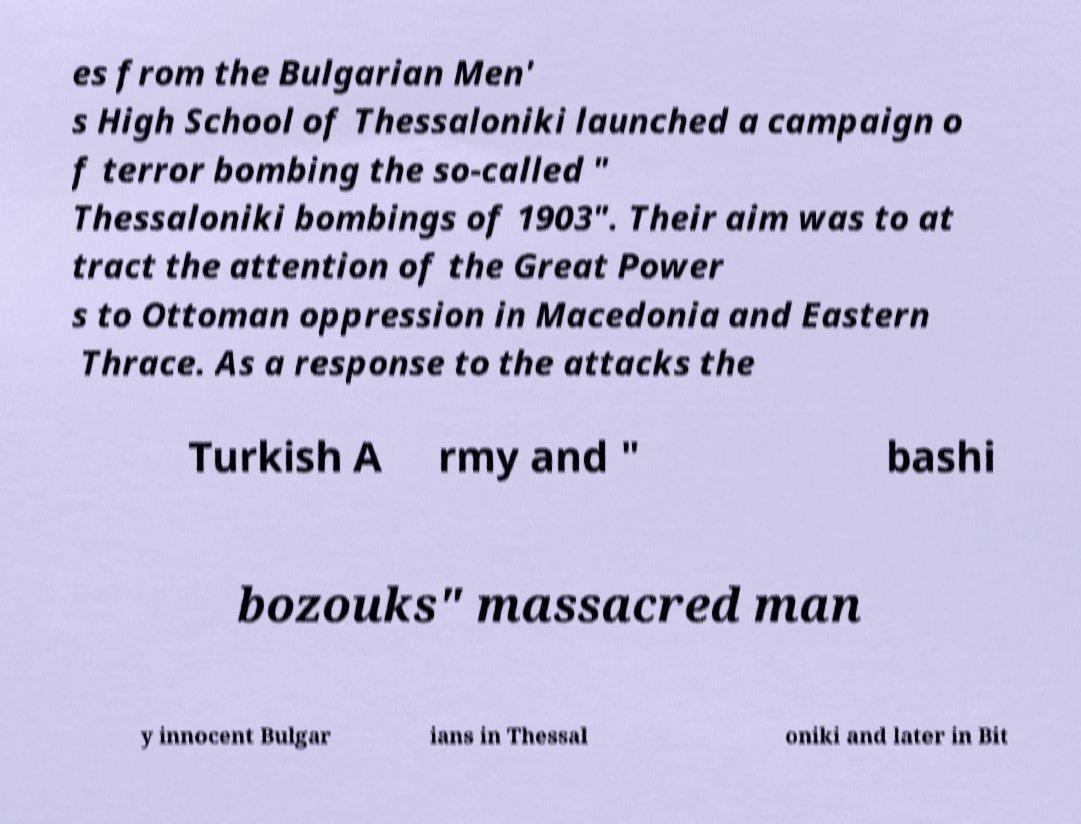I need the written content from this picture converted into text. Can you do that? es from the Bulgarian Men' s High School of Thessaloniki launched a campaign o f terror bombing the so-called " Thessaloniki bombings of 1903". Their aim was to at tract the attention of the Great Power s to Ottoman oppression in Macedonia and Eastern Thrace. As a response to the attacks the Turkish A rmy and " bashi bozouks" massacred man y innocent Bulgar ians in Thessal oniki and later in Bit 